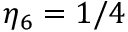Convert formula to latex. <formula><loc_0><loc_0><loc_500><loc_500>\eta _ { 6 } = 1 / 4</formula> 